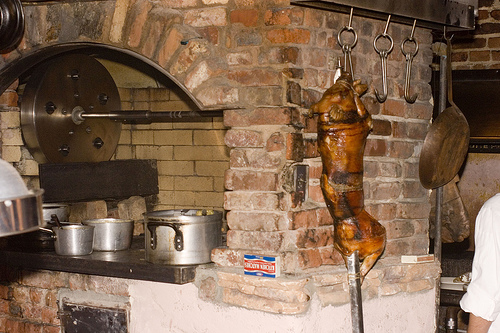<image>
Is there a matches next to the dead pig? Yes. The matches is positioned adjacent to the dead pig, located nearby in the same general area. 